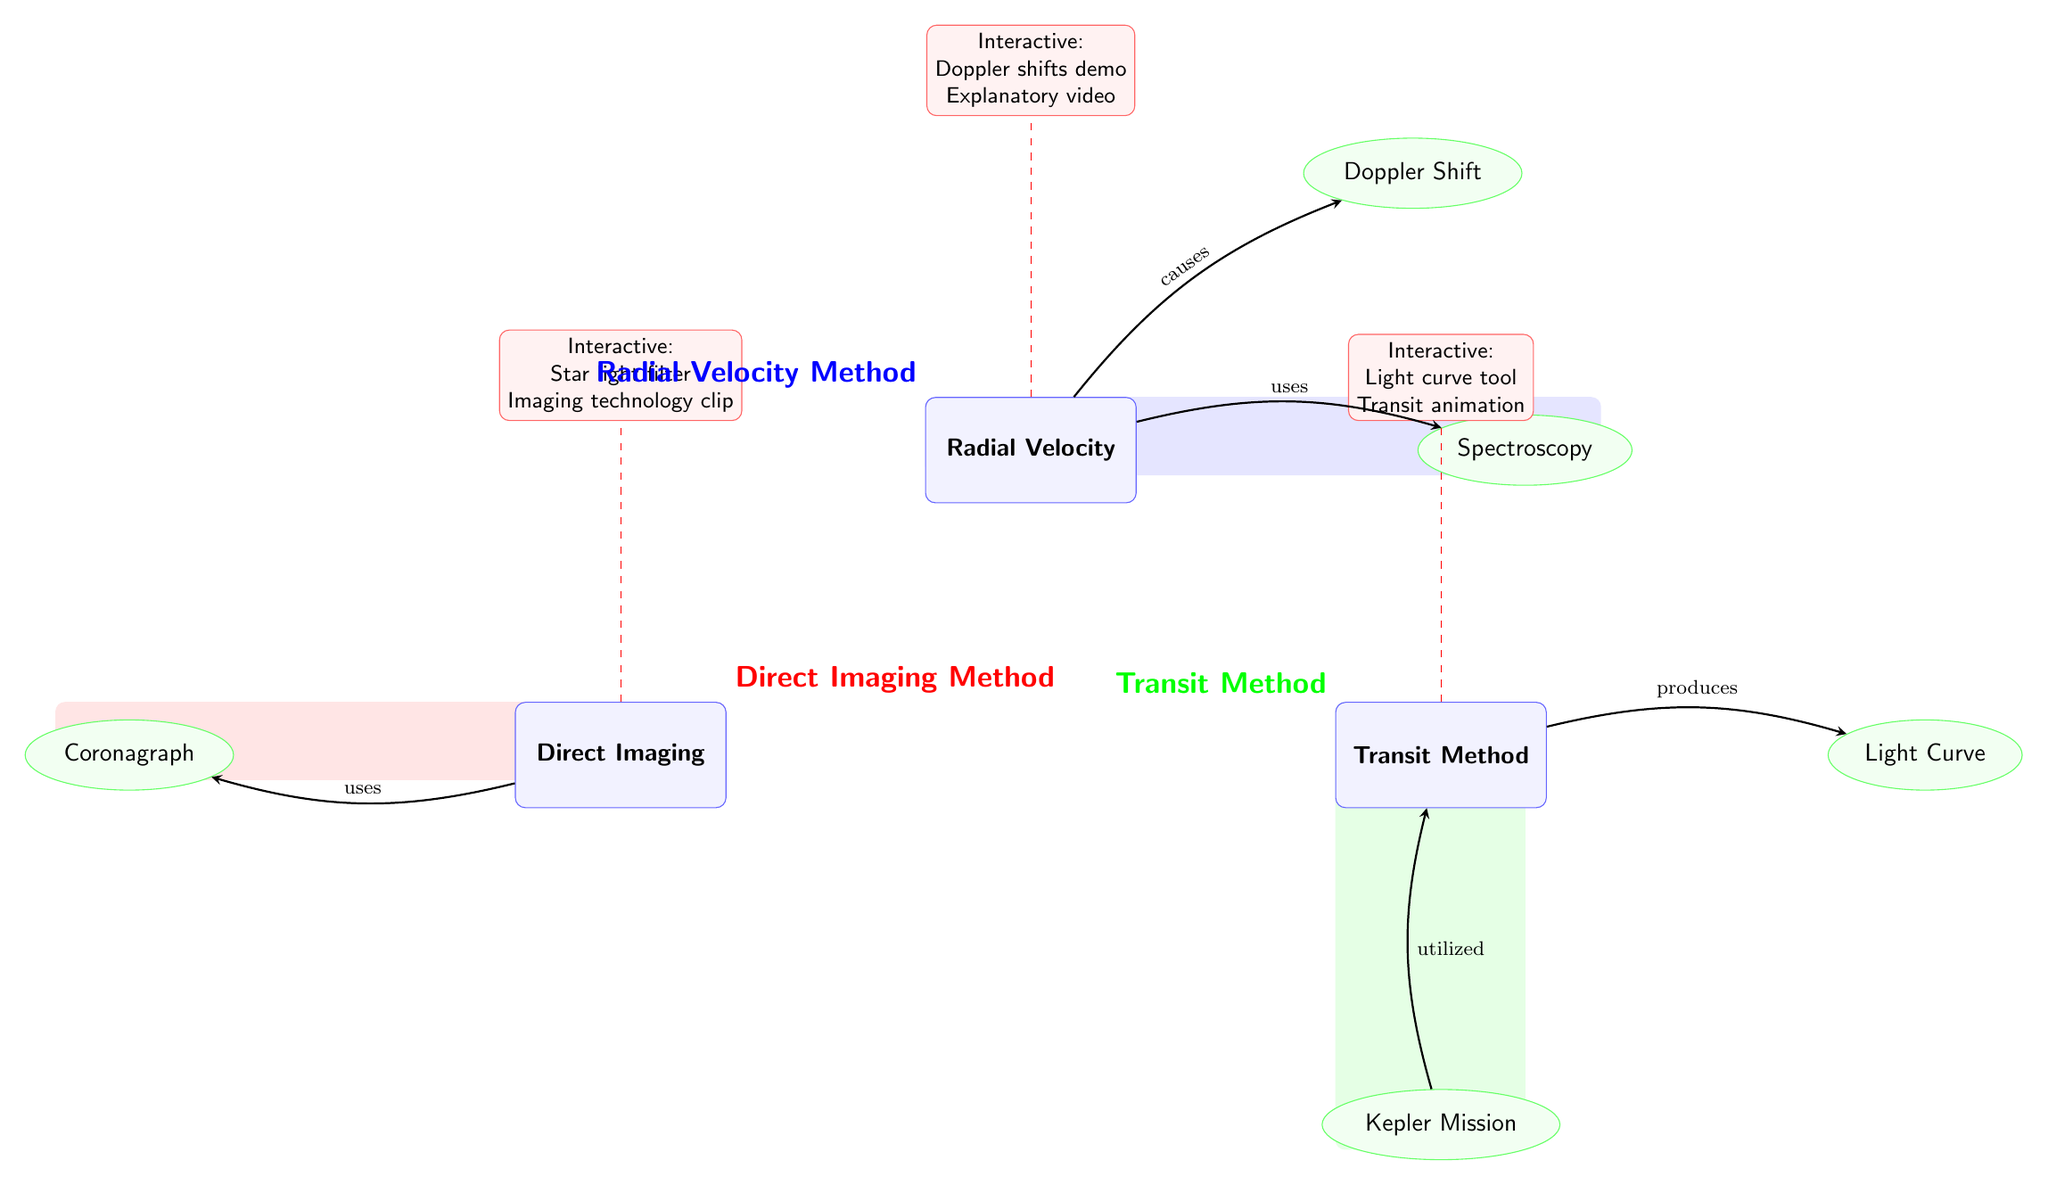What are the three exoplanet detection methods shown? The diagram contains three nodes labeled as "Radial Velocity", "Transit Method", and "Direct Imaging". This indicates that these are the main methods for exoplanet detection highlighted in the diagram.
Answer: Radial Velocity, Transit Method, Direct Imaging Which concept is related to the Radial Velocity method? The diagram shows an arrow pointing from "Radial Velocity" to "Doppler Shift", indicating that Doppler Shift is a related concept. Hence, the relationship confirms that Radial Velocity utilizes Doppler Shift.
Answer: Doppler Shift What interactive element is associated with the Transit Method? The diagram presents a node labeled "Interactive: Light curve tool Transit animation" connected with a dashed line to the "Transit Method". Therefore, this is the interactive element related to the Transit Method.
Answer: Light curve tool, Transit animation How many total concepts are presented in the diagram? By counting the nodes labeled as concepts, we find the following: "Doppler Shift", "Spectroscopy", "Light Curve", "Coronagraph", and "Kepler Mission", resulting in a total of five concepts.
Answer: 5 Which method produces a Light Curve? The diagram includes an arrow going from "Transit Method" to "Light Curve", indicating that the Transit Method is responsible for producing a Light Curve. Thus, the answer is the Transit Method.
Answer: Transit Method What is used by the Direct Imaging method? The arrow in the diagram connecting "Direct Imaging" to "Coronagraph" signifies that the Direct Imaging method makes use of a Coronagraph. Thus, the answer reflects this direct relationship.
Answer: Coronagraph What mission is utilized in the context of the Transit Method? The diagram shows an arrow pointing from "Kepler Mission" to "Transit Method", indicating that the Kepler Mission is associated with or used in the context of the Transit Method.
Answer: Kepler Mission Which method uses Spectroscopy? The arrow leading from "Radial Velocity" to "Spectroscopy" suggests that the Radial Velocity method involves the use of Spectroscopy to detect exoplanets. Thus, the answer is straightforwardly in accordance with the diagram's flow.
Answer: Radial Velocity 